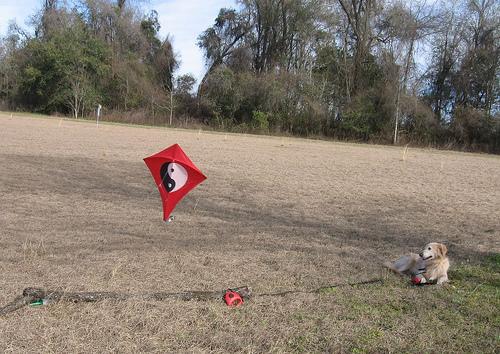What symbol is on the kite?
Give a very brief answer. Yin yang. What type of dog?
Write a very short answer. Golden retriever. What is in the dog's mouth?
Be succinct. Nothing. Is the dog chasing the kite?
Write a very short answer. No. 